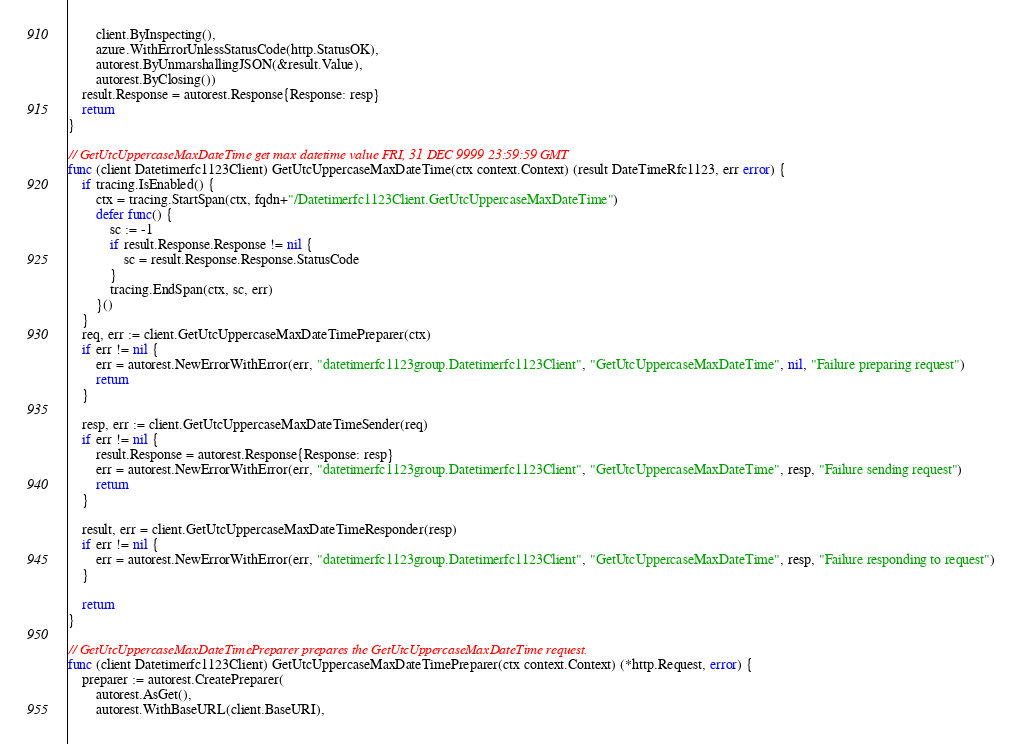<code> <loc_0><loc_0><loc_500><loc_500><_Go_>		client.ByInspecting(),
		azure.WithErrorUnlessStatusCode(http.StatusOK),
		autorest.ByUnmarshallingJSON(&result.Value),
		autorest.ByClosing())
	result.Response = autorest.Response{Response: resp}
	return
}

// GetUtcUppercaseMaxDateTime get max datetime value FRI, 31 DEC 9999 23:59:59 GMT
func (client Datetimerfc1123Client) GetUtcUppercaseMaxDateTime(ctx context.Context) (result DateTimeRfc1123, err error) {
	if tracing.IsEnabled() {
		ctx = tracing.StartSpan(ctx, fqdn+"/Datetimerfc1123Client.GetUtcUppercaseMaxDateTime")
		defer func() {
			sc := -1
			if result.Response.Response != nil {
				sc = result.Response.Response.StatusCode
			}
			tracing.EndSpan(ctx, sc, err)
		}()
	}
	req, err := client.GetUtcUppercaseMaxDateTimePreparer(ctx)
	if err != nil {
		err = autorest.NewErrorWithError(err, "datetimerfc1123group.Datetimerfc1123Client", "GetUtcUppercaseMaxDateTime", nil, "Failure preparing request")
		return
	}

	resp, err := client.GetUtcUppercaseMaxDateTimeSender(req)
	if err != nil {
		result.Response = autorest.Response{Response: resp}
		err = autorest.NewErrorWithError(err, "datetimerfc1123group.Datetimerfc1123Client", "GetUtcUppercaseMaxDateTime", resp, "Failure sending request")
		return
	}

	result, err = client.GetUtcUppercaseMaxDateTimeResponder(resp)
	if err != nil {
		err = autorest.NewErrorWithError(err, "datetimerfc1123group.Datetimerfc1123Client", "GetUtcUppercaseMaxDateTime", resp, "Failure responding to request")
	}

	return
}

// GetUtcUppercaseMaxDateTimePreparer prepares the GetUtcUppercaseMaxDateTime request.
func (client Datetimerfc1123Client) GetUtcUppercaseMaxDateTimePreparer(ctx context.Context) (*http.Request, error) {
	preparer := autorest.CreatePreparer(
		autorest.AsGet(),
		autorest.WithBaseURL(client.BaseURI),</code> 